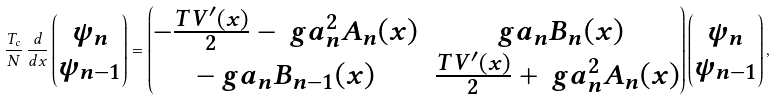Convert formula to latex. <formula><loc_0><loc_0><loc_500><loc_500>\frac { T _ { c } } { N } \, \frac { d } { d x } \begin{pmatrix} \psi _ { n } \\ \psi _ { n - 1 } \end{pmatrix} = \begin{pmatrix} - \frac { T V ^ { \prime } ( x ) } { 2 } - \ g a _ { n } ^ { 2 } A _ { n } ( x ) & \ g a _ { n } B _ { n } ( x ) \\ - \ g a _ { n } B _ { n - 1 } ( x ) & \frac { T V ^ { \prime } ( x ) } { 2 } + \ g a _ { n } ^ { 2 } A _ { n } ( x ) \end{pmatrix} \begin{pmatrix} \psi _ { n } \\ \psi _ { n - 1 } \end{pmatrix} ,</formula> 